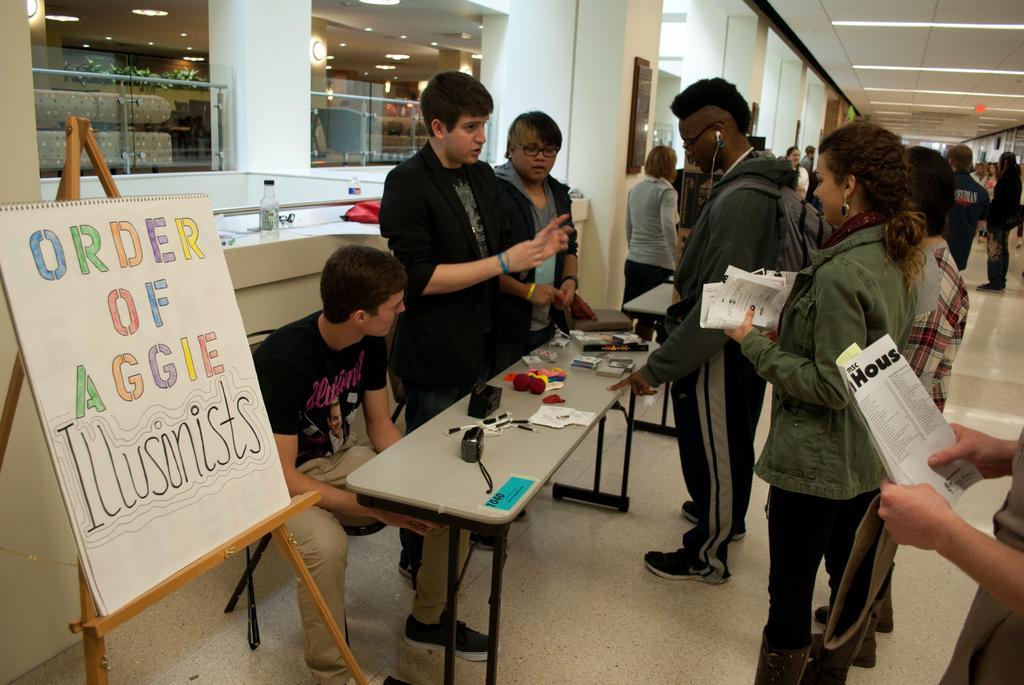Can you describe this image briefly? In this image I can see the man standing and explaining to the people. This is the woman standing and holding the papers on her hand. I can see a man standing and showing some objects on the table. This is a another man holding some papers at right corner of the image. At the background I can see a lot of people standing. This is a photo frame attached to the wall. At background I can see couch and some plants were placed ,Chairs. This is water bottle placed on the wall. and this is a kind of red color object placed on the wall. This is a board some message is written on it. This is a table were camera and some other objects were placed on it. 